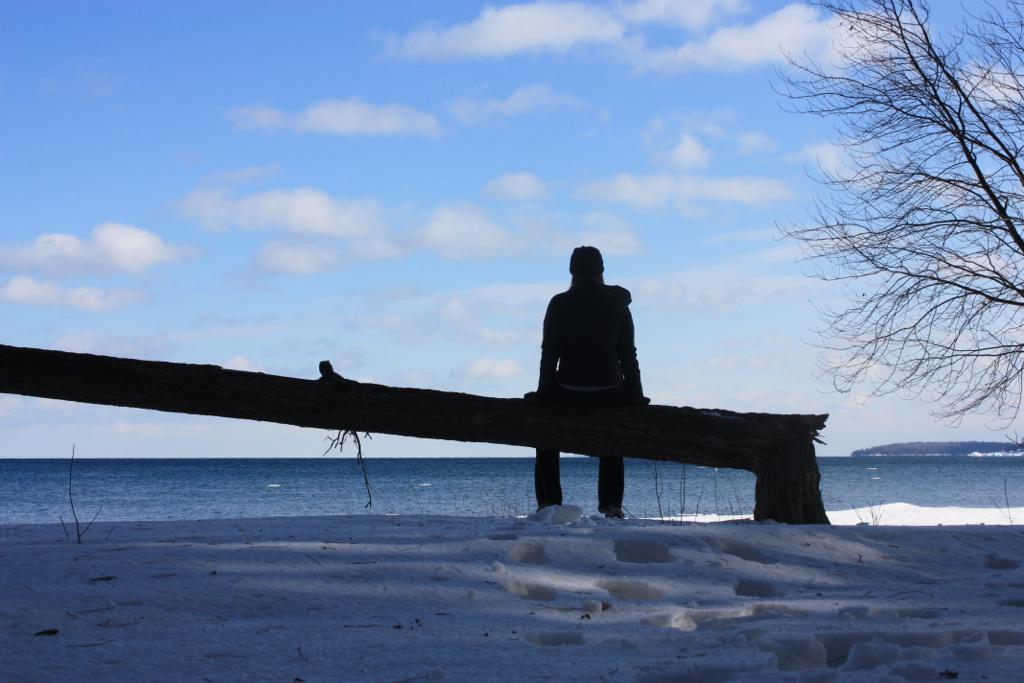Describe this image in one or two sentences. In this image, we can see a person is sitting on a wooden pole. At the bottom, we can see snow. Background there is a sky. Here we can see few plants and sky. 